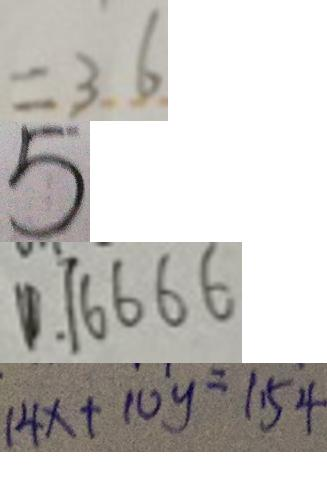Convert formula to latex. <formula><loc_0><loc_0><loc_500><loc_500>= 3 . 6 
 5 
 0 . 1 6 6 6 6 
 1 4 x + 1 0 y = 1 \cdot 5 4</formula> 